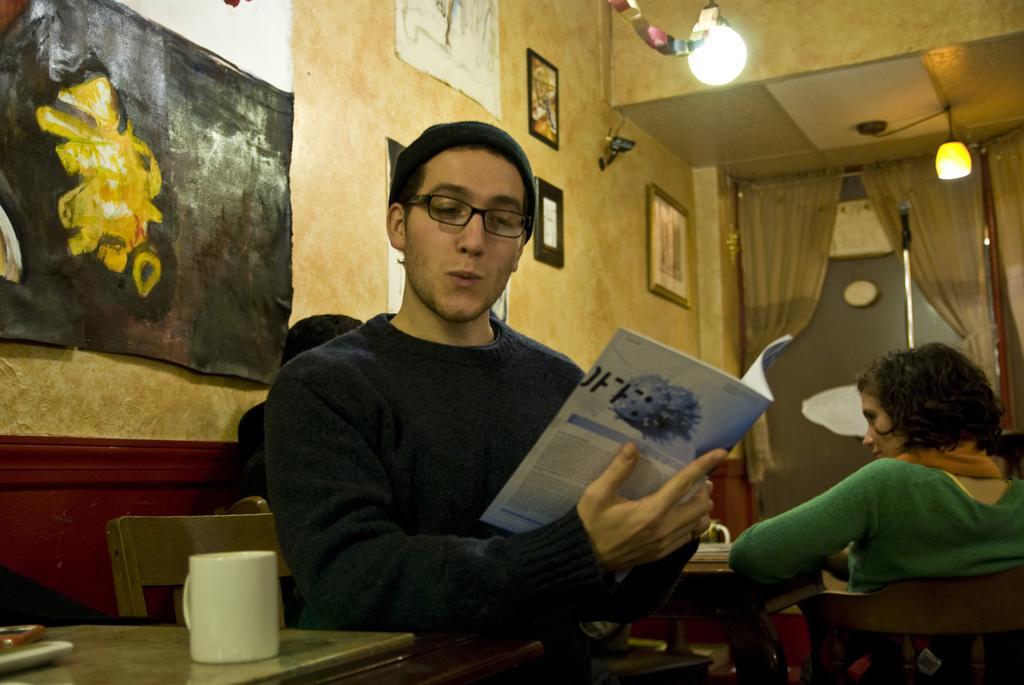Can you describe this image briefly? There is a person sitting and wearing cap and specs. Also holding a book. In front of her there is a table. On that there is a cup. In the back there are some people sitting on chairs. On the wall there are painting, lights. In the background there are curtains. Also there is a mic with stand. 